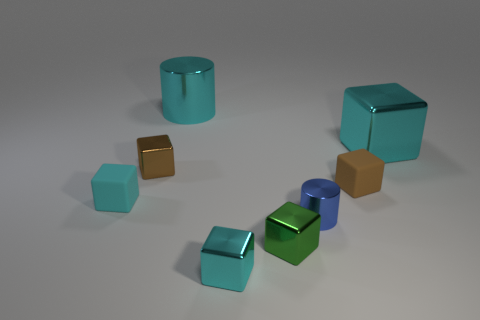There is a small rubber thing that is in front of the tiny brown matte cube; is it the same color as the small metal cube that is in front of the green metal object? No, the small rubber object in front of the tiny brown matte cube is not the same color as the small metal cube in front of the green metal object. The rubber object appears to be mustard yellow, while the small metal cube is teal, indicating a color difference. 